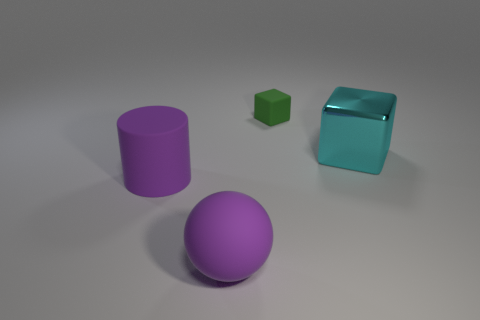Is there anything else that has the same size as the green thing?
Offer a terse response. No. Does the green object have the same material as the cyan object?
Offer a terse response. No. How many big purple spheres are behind the matte sphere?
Offer a terse response. 0. What size is the other thing that is the same shape as the big cyan object?
Provide a short and direct response. Small. How many brown objects are tiny cylinders or big shiny objects?
Give a very brief answer. 0. What number of rubber things are right of the rubber object that is to the left of the purple ball?
Make the answer very short. 2. What number of other objects are the same shape as the metal object?
Offer a terse response. 1. There is a thing that is the same color as the big rubber ball; what is its material?
Ensure brevity in your answer.  Rubber. How many large rubber things have the same color as the big cylinder?
Keep it short and to the point. 1. There is a big object that is the same material as the cylinder; what color is it?
Provide a succinct answer. Purple. 